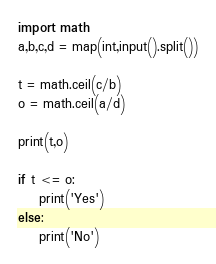Convert code to text. <code><loc_0><loc_0><loc_500><loc_500><_Python_>import math
a,b,c,d = map(int,input().split())

t = math.ceil(c/b)
o = math.ceil(a/d)

print(t,o)

if t <= o:
    print('Yes')
else:
    print('No')</code> 